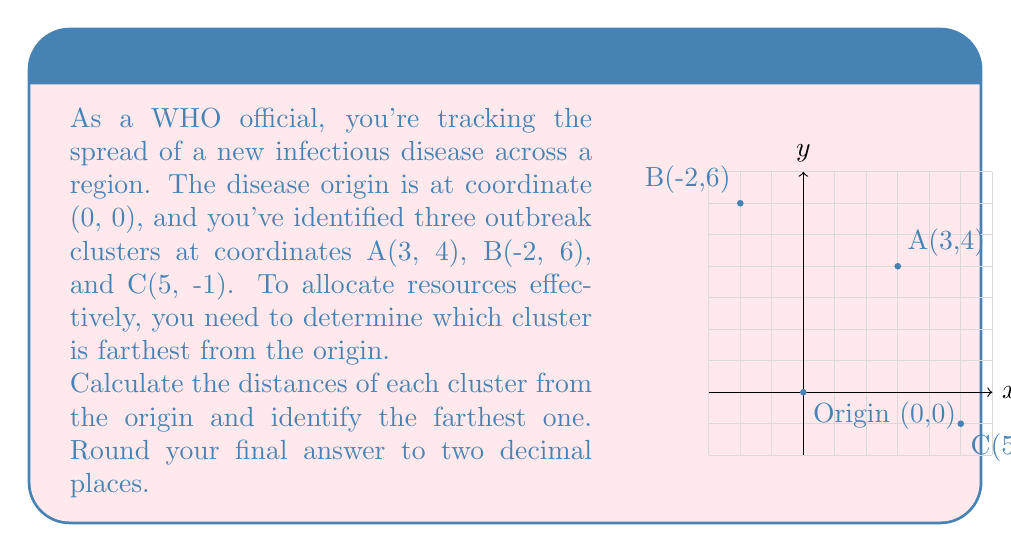Can you answer this question? To solve this problem, we'll use the distance formula derived from the Pythagorean theorem:

$$d = \sqrt{(x_2-x_1)^2 + (y_2-y_1)^2}$$

Where $(x_1,y_1)$ is the origin (0,0) and $(x_2,y_2)$ is the coordinate of each cluster.

Step 1: Calculate the distance for cluster A(3,4)
$$d_A = \sqrt{(3-0)^2 + (4-0)^2} = \sqrt{3^2 + 4^2} = \sqrt{9 + 16} = \sqrt{25} = 5$$

Step 2: Calculate the distance for cluster B(-2,6)
$$d_B = \sqrt{(-2-0)^2 + (6-0)^2} = \sqrt{(-2)^2 + 6^2} = \sqrt{4 + 36} = \sqrt{40} \approx 6.32$$

Step 3: Calculate the distance for cluster C(5,-1)
$$d_C = \sqrt{(5-0)^2 + (-1-0)^2} = \sqrt{5^2 + (-1)^2} = \sqrt{25 + 1} = \sqrt{26} \approx 5.10$$

Step 4: Compare the distances
$d_A = 5$
$d_B \approx 6.32$
$d_C \approx 5.10$

The largest distance is $d_B \approx 6.32$, corresponding to cluster B(-2,6).
Answer: B(-2,6), 6.32 units 